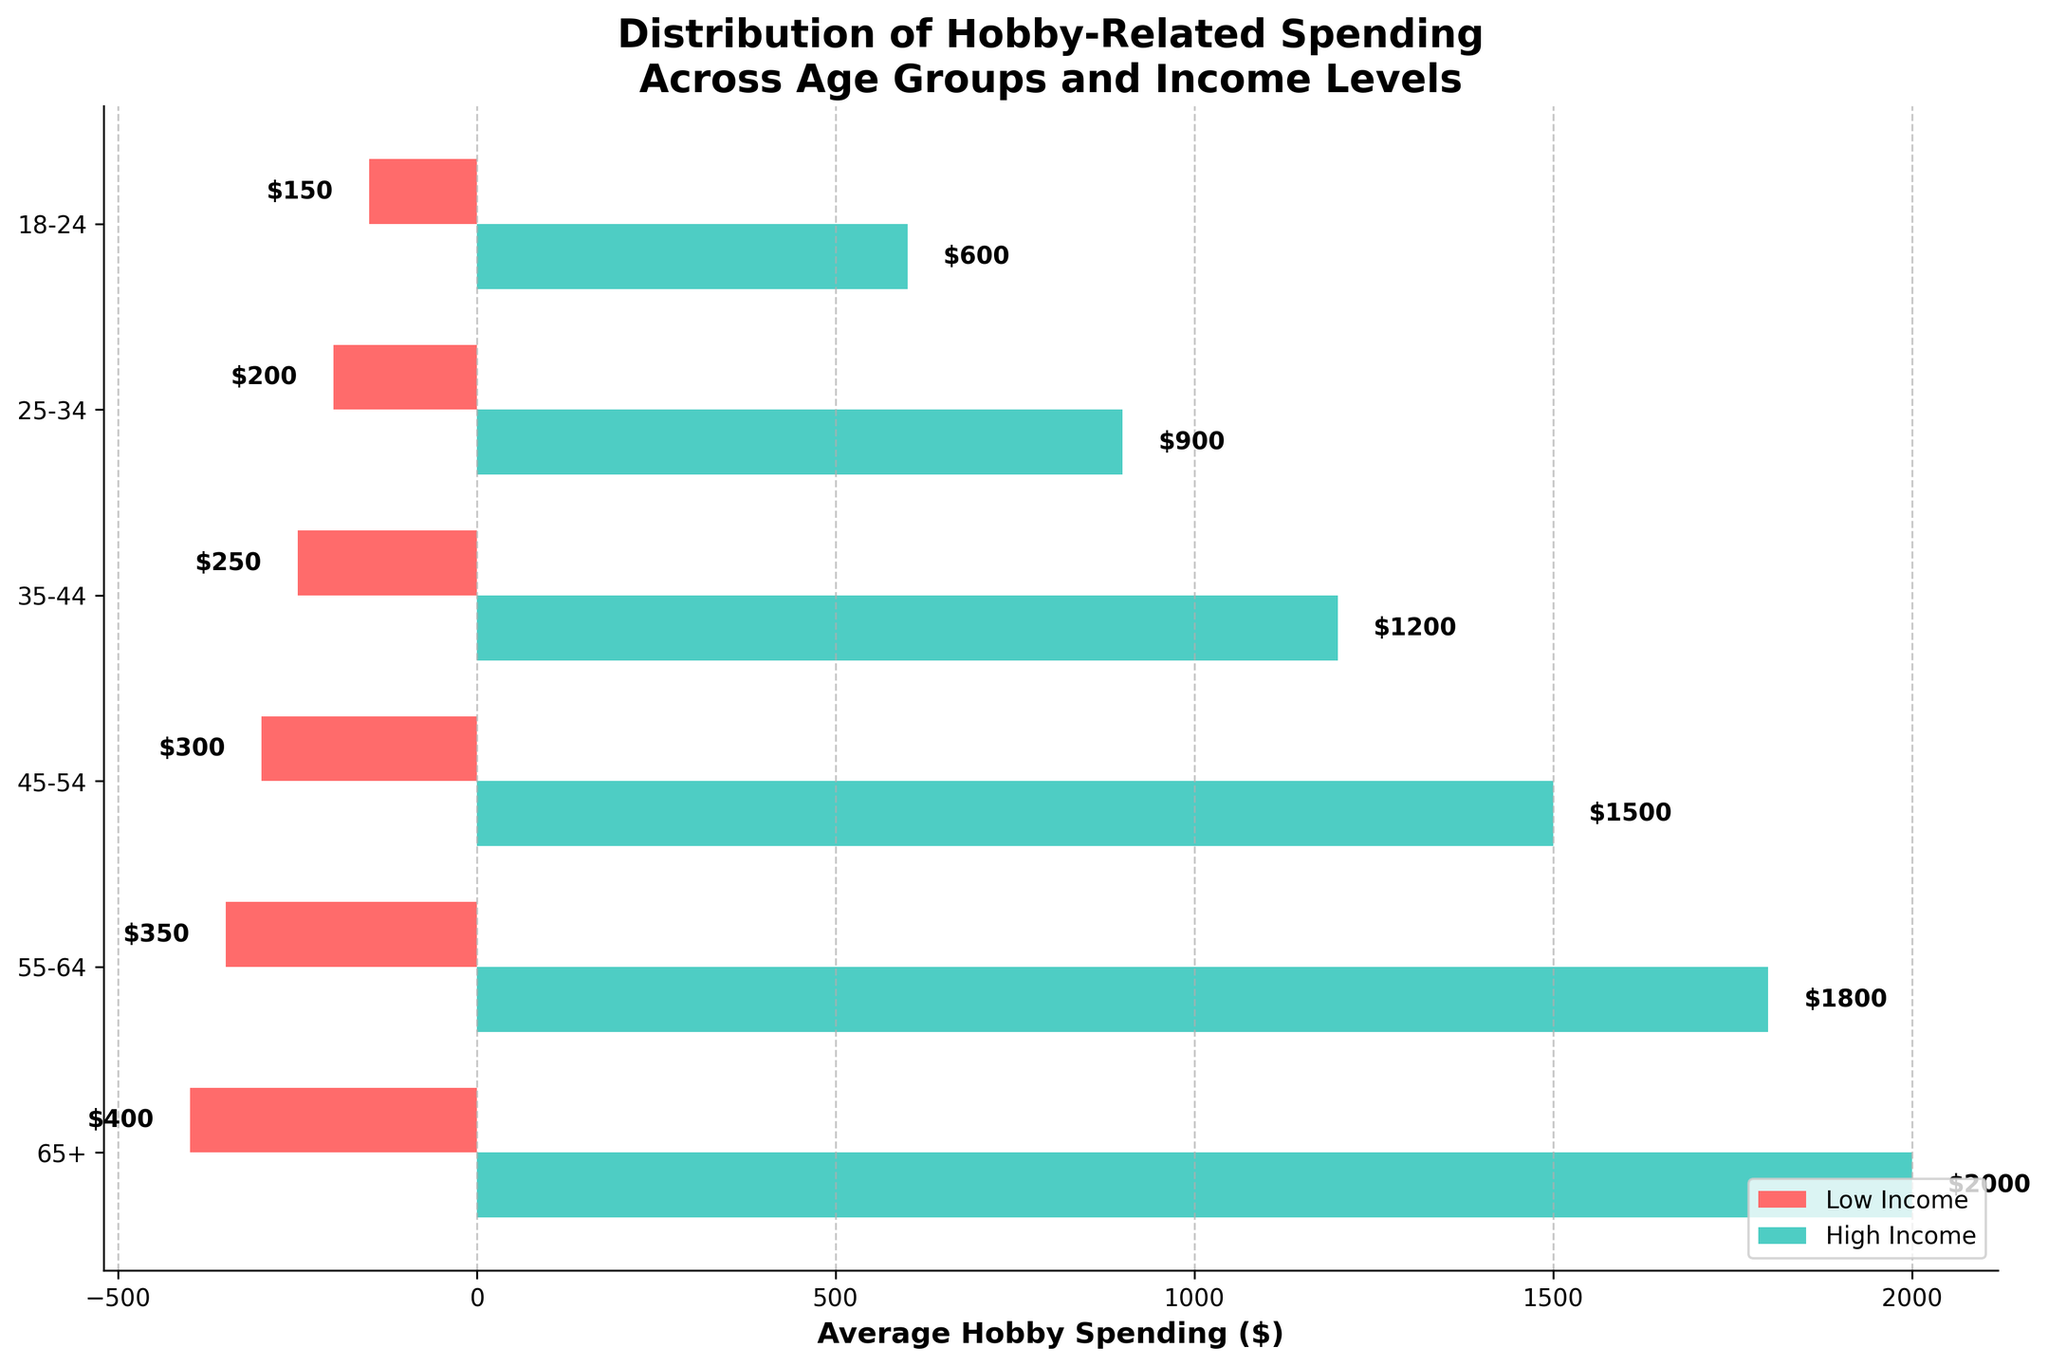What's the title of the plot? The title is written at the top of the plot. It reads "Distribution of Hobby-Related Spending Across Age Groups and Income Levels."
Answer: Distribution of Hobby-Related Spending Across Age Groups and Income Levels Which age group spends the least on hobbies for low-income individuals? For low-income individuals, the bar that extends the least to the left represents the least spending. The 18-24 age group spends $150 on average.
Answer: 18-24 What's the average spending on hobbies for high-income individuals aged 45-54? Identify the bar corresponding to high-income individuals in the 45-54 age group. The bar extends to $1500.
Answer: $1500 How does the hobby spending in the 25-34 age group compare between low and high income? Compare the lengths of the bars for the 25-34 age group: low-income spending is $200, and high-income spending is $900. The difference is $900 - $200 = $700.
Answer: High-income spending is $700 more than low-income spending What is the difference in spending between the highest and the lowest income levels for the 65+ age group? For the 65+ age group, low-income spending is $400, and high-income spending is $2000. The difference is $2000 - $400 = $1600.
Answer: $1600 Which age group has the smallest difference in hobby spending between low and high-income levels? Calculate the difference in spending for all age groups and identify the smallest difference. For the 18-24 group: $600 - $150 = $450, 25-34 group: $900 - $200 = $700, 35-44 group: $1200 - $250 = $950, 45-54 group: $1500 - $300 = $1200, 55-64 group: $1800 - $350 = $1450, 65+ group: $2000 - $400 = $1600. The smallest difference is $450 for the 18-24 age group.
Answer: 18-24 What is the overall trend in hobby spending as income level increases within each age group? For each age group, compare the bars for low income and high income. Spending consistently increases from low income to high income across all age groups.
Answer: Spending increases with income level What is the total average hobby spending for all age groups for low-income individuals? Sum the spending amounts for low-income individuals across all age groups: $150 (18-24) + $200 (25-34) + $250 (35-44) + $300 (45-54) + $350 (55-64) + $400 (65+). The total is $1650.
Answer: $1650 In which age group do high-income individuals spend the most on hobbies? Identify the bar for high-income individuals that extends the furthest to the right. The 65+ age group spends $2000, the highest of all groups.
Answer: 65+ 